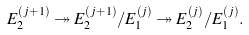<formula> <loc_0><loc_0><loc_500><loc_500>E _ { 2 } ^ { ( j + 1 ) } \twoheadrightarrow E _ { 2 } ^ { ( j + 1 ) } / E _ { 1 } ^ { ( j ) } \twoheadrightarrow E _ { 2 } ^ { ( j ) } / E _ { 1 } ^ { ( j ) } .</formula> 